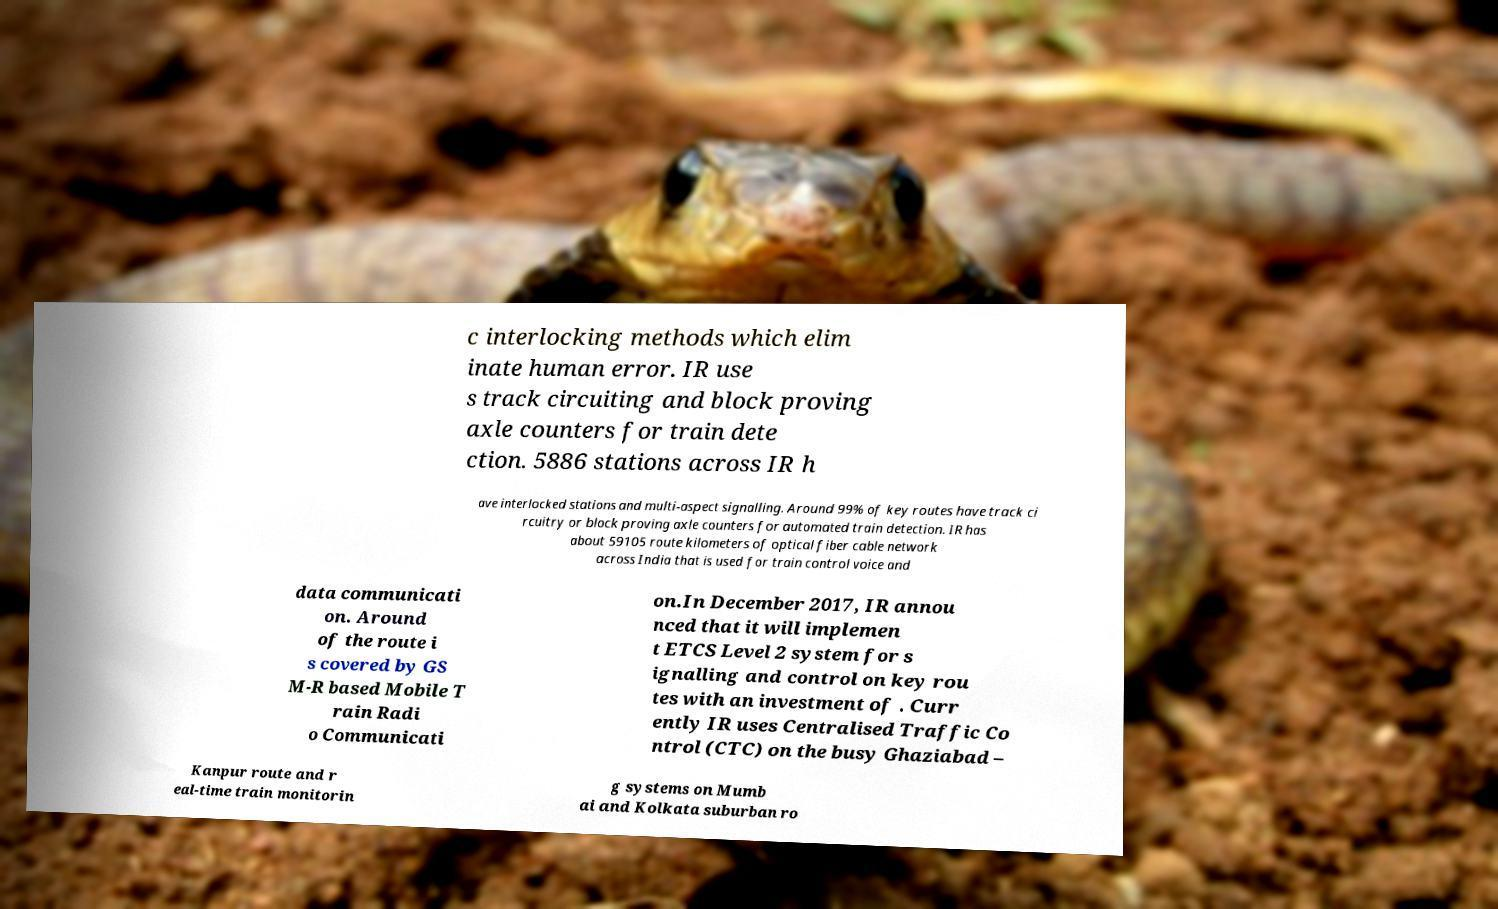Please identify and transcribe the text found in this image. c interlocking methods which elim inate human error. IR use s track circuiting and block proving axle counters for train dete ction. 5886 stations across IR h ave interlocked stations and multi-aspect signalling. Around 99% of key routes have track ci rcuitry or block proving axle counters for automated train detection. IR has about 59105 route kilometers of optical fiber cable network across India that is used for train control voice and data communicati on. Around of the route i s covered by GS M-R based Mobile T rain Radi o Communicati on.In December 2017, IR annou nced that it will implemen t ETCS Level 2 system for s ignalling and control on key rou tes with an investment of . Curr ently IR uses Centralised Traffic Co ntrol (CTC) on the busy Ghaziabad – Kanpur route and r eal-time train monitorin g systems on Mumb ai and Kolkata suburban ro 